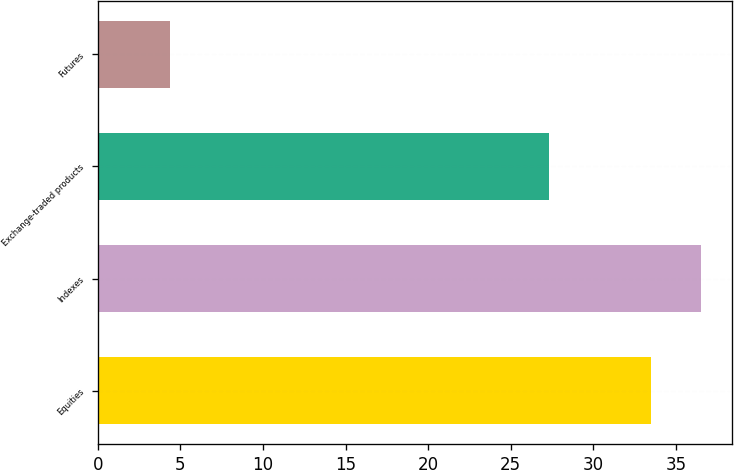Convert chart. <chart><loc_0><loc_0><loc_500><loc_500><bar_chart><fcel>Equities<fcel>Indexes<fcel>Exchange-traded products<fcel>Futures<nl><fcel>33.5<fcel>36.54<fcel>27.3<fcel>4.4<nl></chart> 